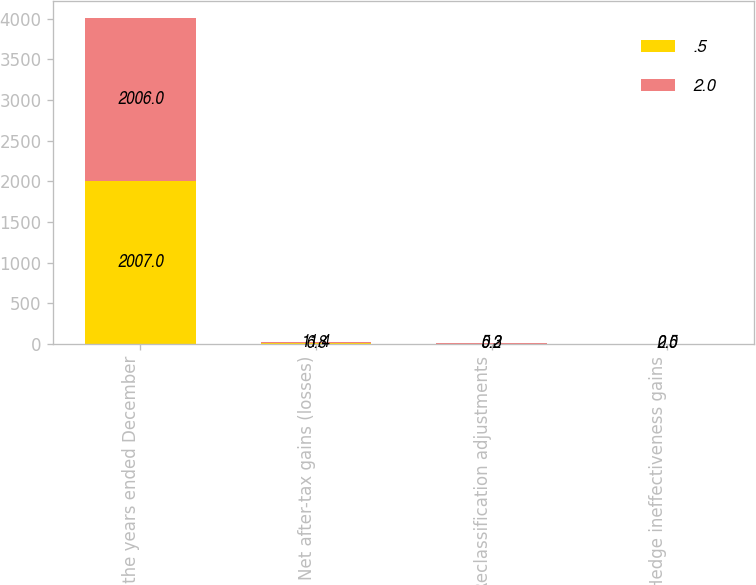Convert chart. <chart><loc_0><loc_0><loc_500><loc_500><stacked_bar_chart><ecel><fcel>For the years ended December<fcel>Net after-tax gains (losses)<fcel>Reclassification adjustments<fcel>Hedge ineffectiveness gains<nl><fcel>0.5<fcel>2007<fcel>6.8<fcel>0.2<fcel>0.5<nl><fcel>2<fcel>2006<fcel>11.4<fcel>5.3<fcel>2<nl></chart> 